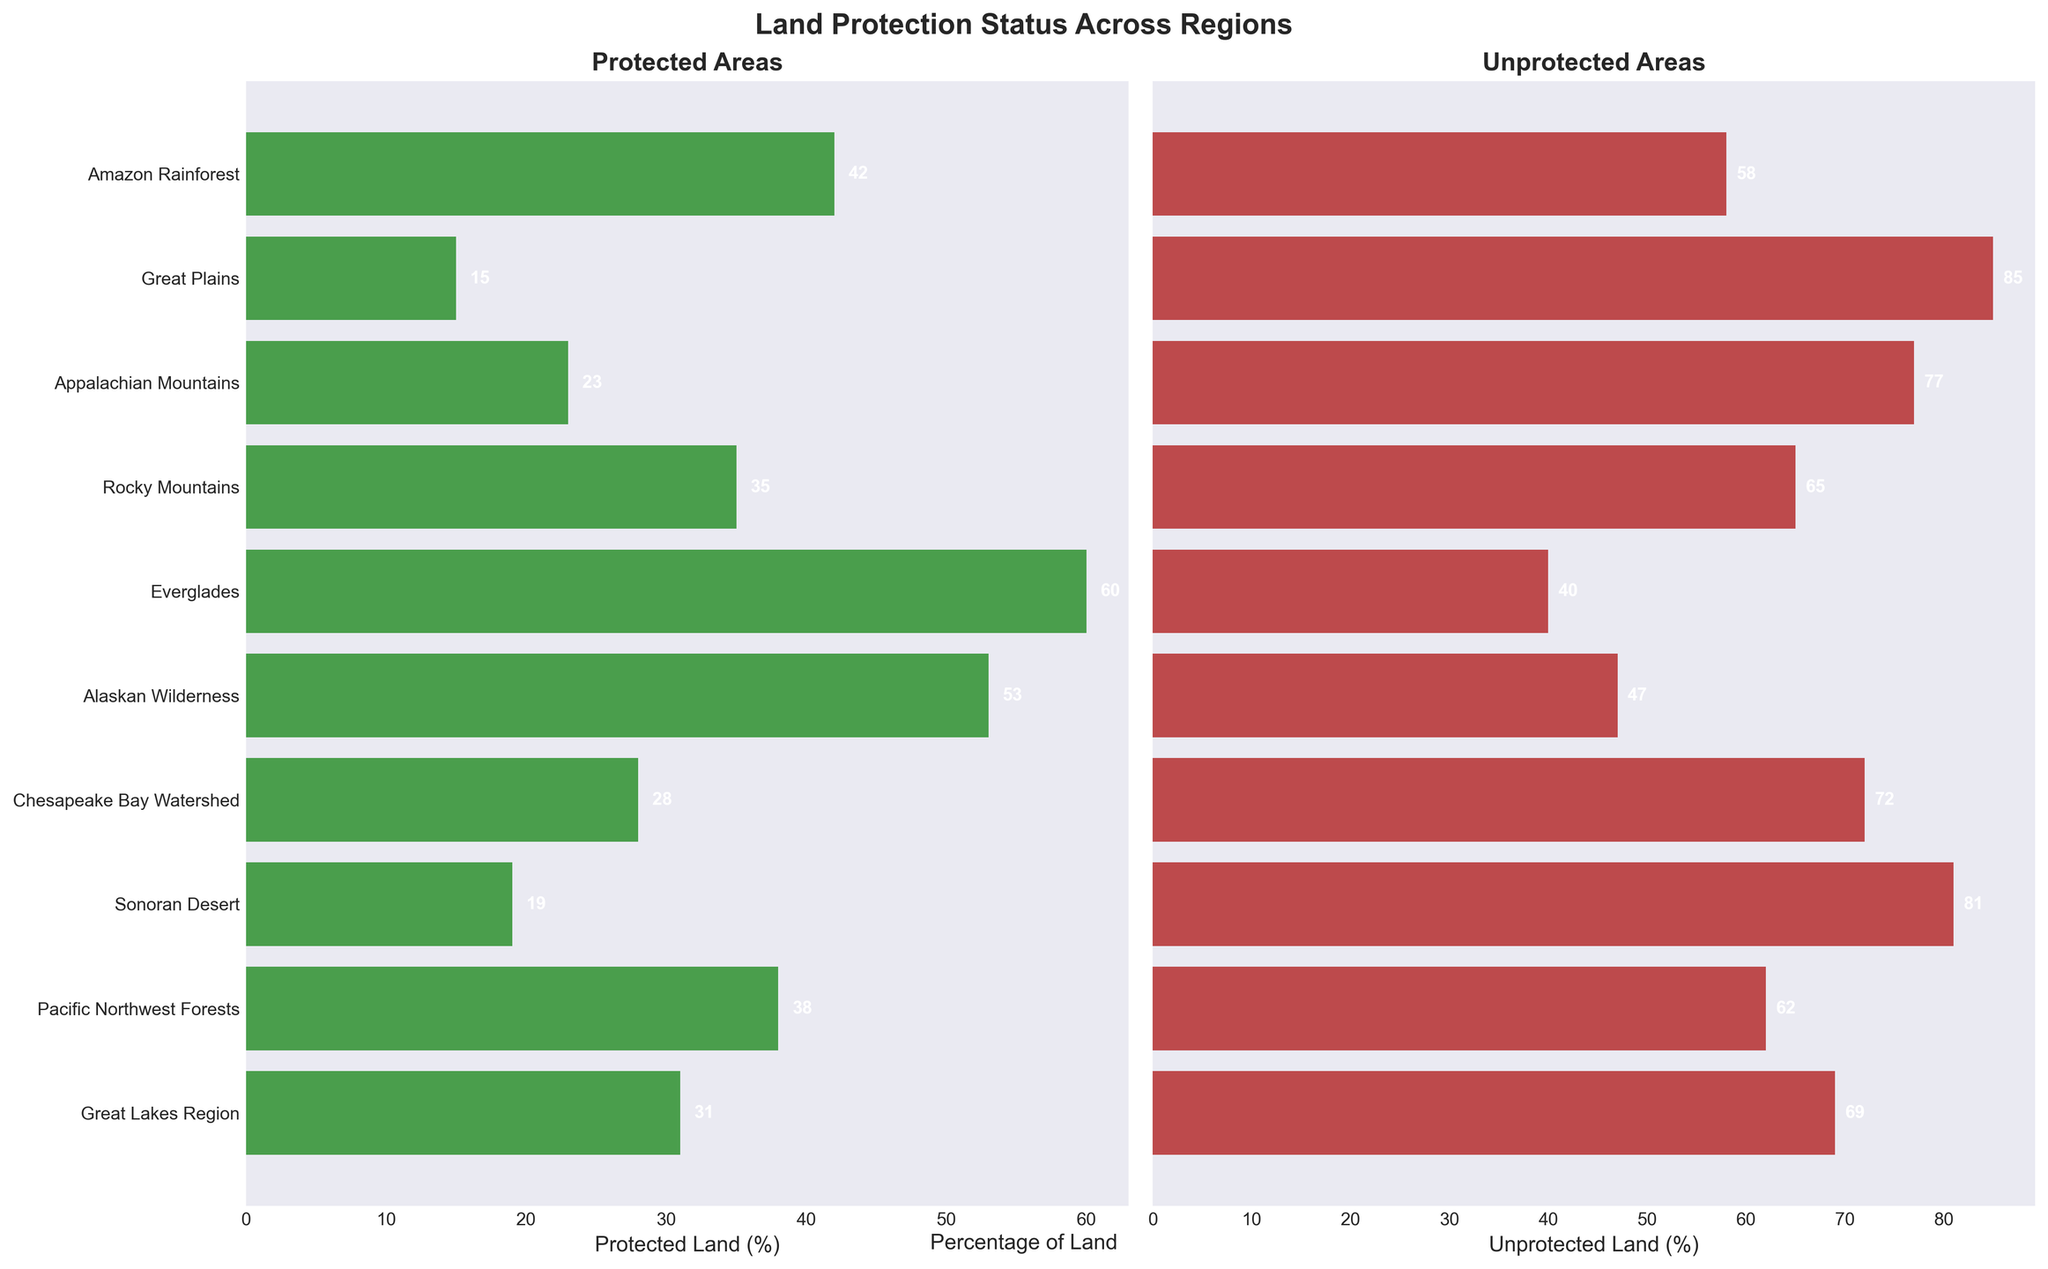What is the title of the figure? The title is located at the top center of the figure and reads "Land Protection Status Across Regions."
Answer: Land Protection Status Across Regions Which region has the highest percentage of protected land? By looking at the "Protected Areas" subplot on the left, the Everglades region has the highest bar, indicating the highest percentage of protected land.
Answer: Everglades Which region has more unprotected land, the Great Plains or the Great Lakes Region? By comparing the lengths of the bars in the "Unprotected Areas" subplot on the right, the bar for the Great Plains (85%) is longer than the bar for the Great Lakes Region (69%).
Answer: Great Plains What is the difference in the percentage of protected land between the Amazon Rainforest and the Appalachian Mountains? From the "Protected Areas" subplot, the Amazon Rainforest has 42% protected land, and the Appalachian Mountains have 23%. The difference is calculated as 42 - 23.
Answer: 19 What is the average percentage of protected land across all the regions? Add the percentages of protected land for all regions (42 + 15 + 23 + 35 + 60 + 53 + 28 + 19 + 38 + 31) and divide by the number of regions (10). The calculation is (42 + 15 + 23 + 35 + 60 + 53 + 28 + 19 + 38 + 31) / 10 = 34.4.
Answer: 34.4 How many regions have less than 30% protected land? Count the regions with bars shorter than 30% in the "Protected Areas" subplot. The regions are Great Plains, Appalachian Mountains, Chesapeake Bay Watershed, and Sonoran Desert, which total 4.
Answer: 4 Which region has a higher percentage of protected land, the Pacific Northwest Forests or the Rocky Mountains? By comparing the bars in the "Protected Areas" subplot, the Pacific Northwest Forests (38%) has a shorter bar than the Rocky Mountains (35%).
Answer: Rocky Mountains What percentage of land is unprotected in the Alaskan Wilderness? Looking at the "Unprotected Areas" subplot, the Alaskan Wilderness has an unprotected land percentage of 47%, which is indicated directly by the bar value.
Answer: 47 Rank the regions from highest to lowest percentage of unprotected land. Read the values from the "Unprotected Areas" subplot and list them in descending order: Great Plains (85%), Sonoran Desert (81%), Appalachian Mountains (77%), Chesapeake Bay Watershed (72%), Great Lakes Region (69%), Pacific Northwest Forests (62%), Rocky Mountains (65%), Amazon Rainforest (58%), Alaskan Wilderness (47%), Everglades (40%).
Answer: Great Plains, Sonoran Desert, Appalachian Mountains, Chesapeake Bay Watershed, Great Lakes Region, Rocky Mountains, Pacific Northwest Forests, Amazon Rainforest, Alaskan Wilderness, Everglades What is the total percentage of unprotected land among the regions with more than 50% protected land? Identify the regions with more than 50% protected land: Everglades (60%) and Alaskan Wilderness (53%). Sum their unprotected land percentages: 40% (Everglades) + 47% (Alaskan Wilderness).
Answer: 87 